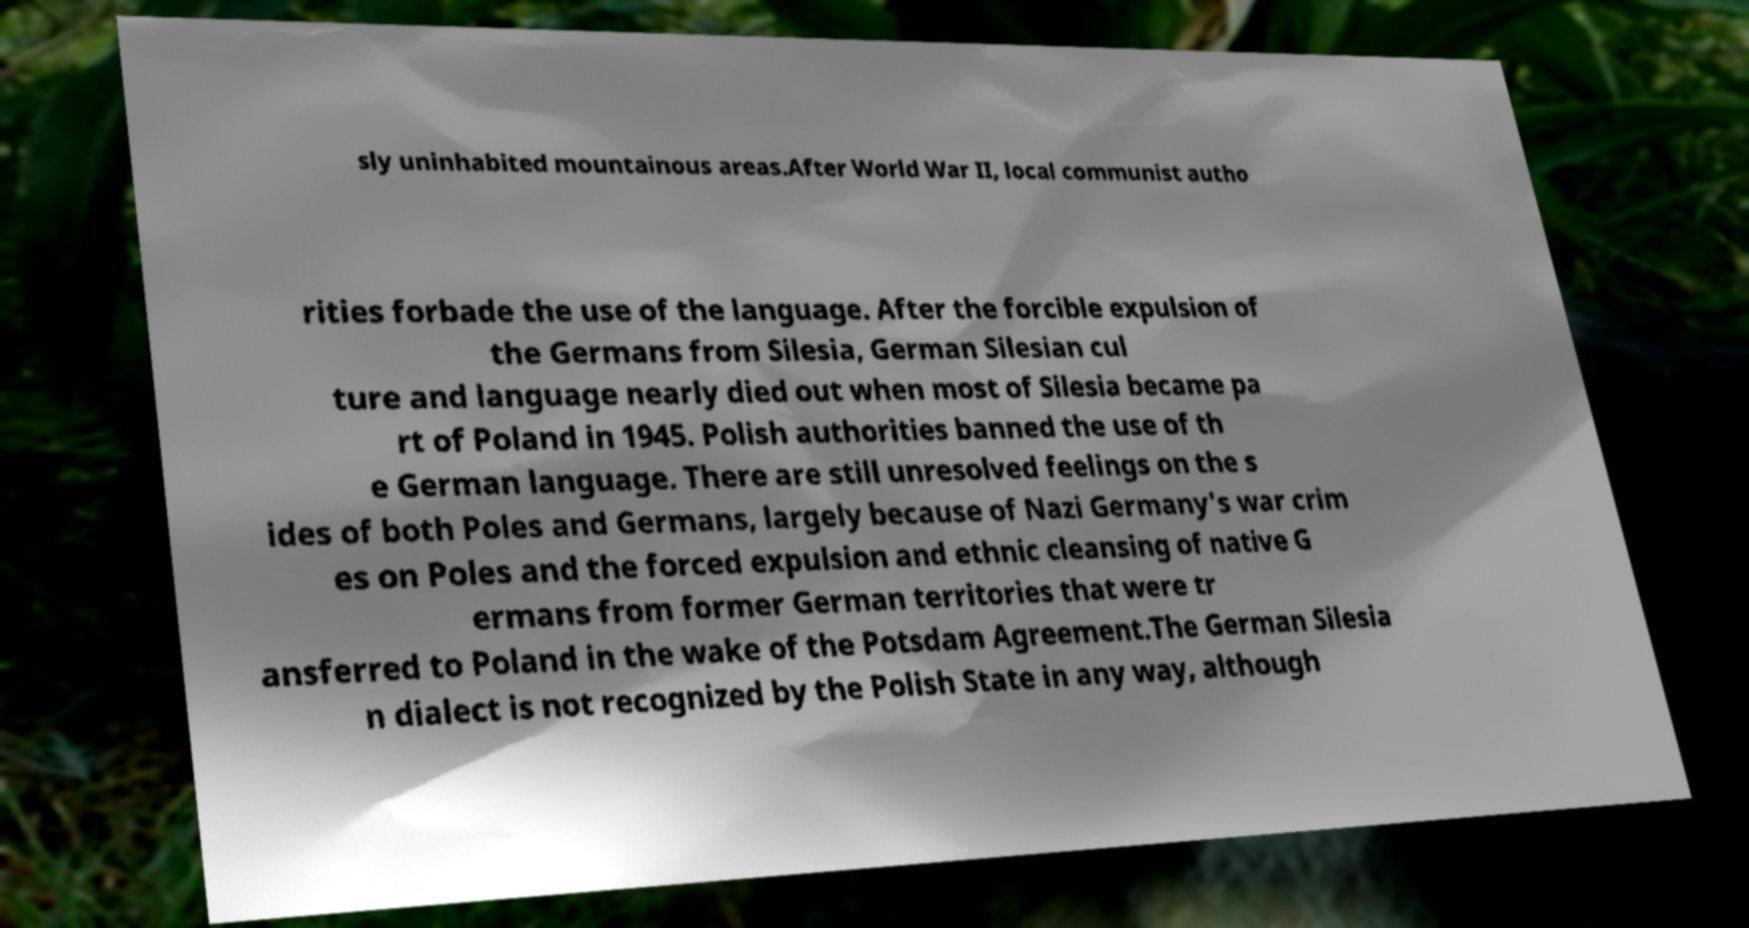There's text embedded in this image that I need extracted. Can you transcribe it verbatim? sly uninhabited mountainous areas.After World War II, local communist autho rities forbade the use of the language. After the forcible expulsion of the Germans from Silesia, German Silesian cul ture and language nearly died out when most of Silesia became pa rt of Poland in 1945. Polish authorities banned the use of th e German language. There are still unresolved feelings on the s ides of both Poles and Germans, largely because of Nazi Germany's war crim es on Poles and the forced expulsion and ethnic cleansing of native G ermans from former German territories that were tr ansferred to Poland in the wake of the Potsdam Agreement.The German Silesia n dialect is not recognized by the Polish State in any way, although 